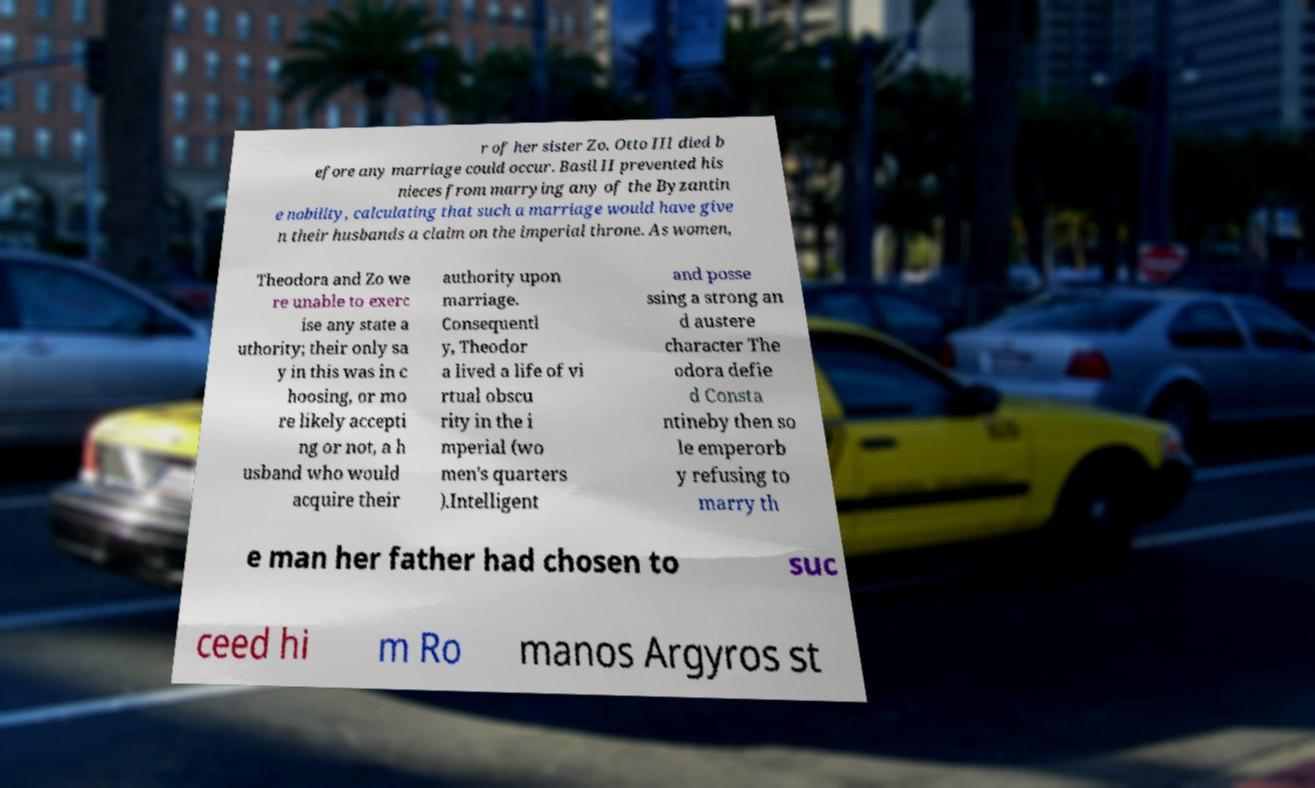Please read and relay the text visible in this image. What does it say? r of her sister Zo. Otto III died b efore any marriage could occur. Basil II prevented his nieces from marrying any of the Byzantin e nobility, calculating that such a marriage would have give n their husbands a claim on the imperial throne. As women, Theodora and Zo we re unable to exerc ise any state a uthority; their only sa y in this was in c hoosing, or mo re likely accepti ng or not, a h usband who would acquire their authority upon marriage. Consequentl y, Theodor a lived a life of vi rtual obscu rity in the i mperial (wo men's quarters ).Intelligent and posse ssing a strong an d austere character The odora defie d Consta ntineby then so le emperorb y refusing to marry th e man her father had chosen to suc ceed hi m Ro manos Argyros st 